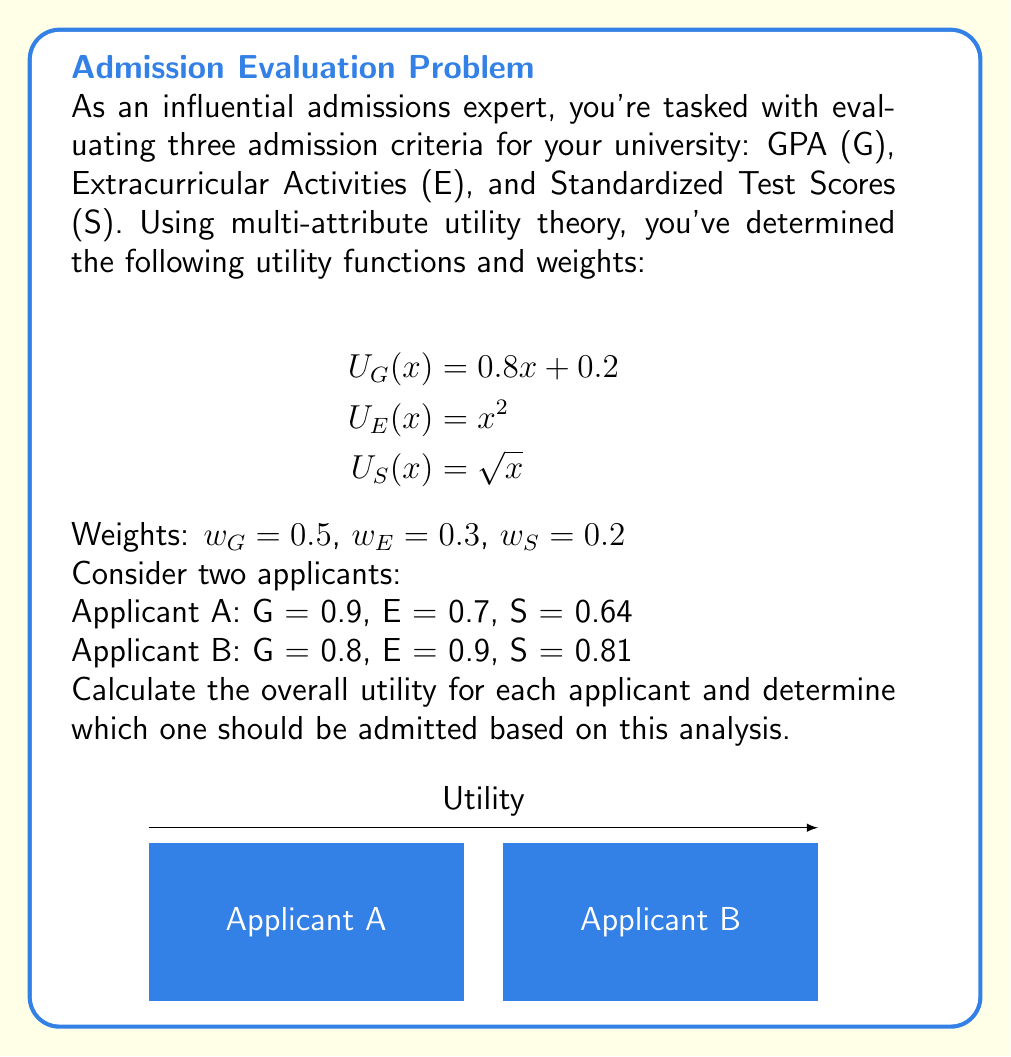Solve this math problem. Let's approach this step-by-step using multi-attribute utility theory:

1) First, we need to calculate the utility for each attribute for both applicants:

For Applicant A:
   G: $U_G(0.9) = 0.8(0.9) + 0.2 = 0.92$
   E: $U_E(0.7) = 0.7^2 = 0.49$
   S: $U_S(0.64) = \sqrt{0.64} = 0.8$

For Applicant B:
   G: $U_G(0.8) = 0.8(0.8) + 0.2 = 0.84$
   E: $U_E(0.9) = 0.9^2 = 0.81$
   S: $U_S(0.81) = \sqrt{0.81} = 0.9$

2) Now, we calculate the weighted sum of these utilities for each applicant:

For Applicant A:
   $U_A = 0.5(0.92) + 0.3(0.49) + 0.2(0.8)$
        $= 0.46 + 0.147 + 0.16$
        $= 0.767$

For Applicant B:
   $U_B = 0.5(0.84) + 0.3(0.81) + 0.2(0.9)$
        $= 0.42 + 0.243 + 0.18$
        $= 0.843$

3) Comparing the overall utilities:
   Applicant A: 0.767
   Applicant B: 0.843

Therefore, based on this analysis, Applicant B has a higher overall utility and should be admitted.
Answer: Admit Applicant B (overall utility 0.843 vs 0.767 for Applicant A) 